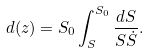Convert formula to latex. <formula><loc_0><loc_0><loc_500><loc_500>d ( z ) = S _ { 0 } \int _ { S } ^ { S _ { 0 } } \frac { d S } { S \dot { S } } .</formula> 